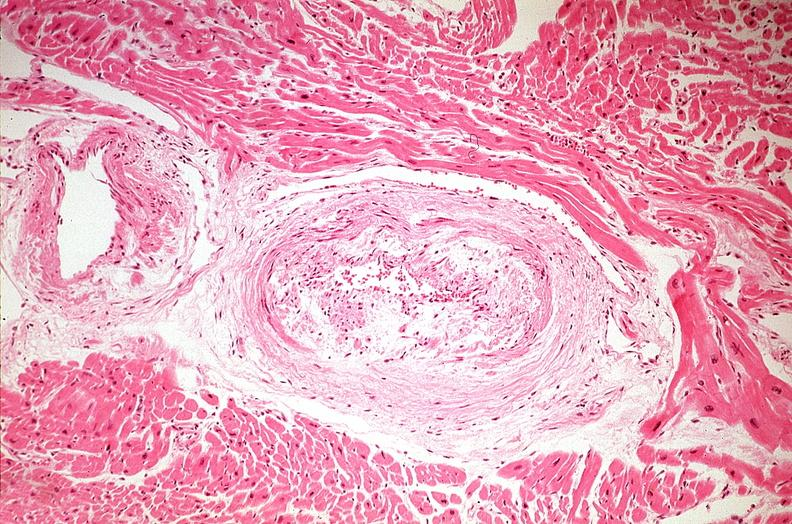what does this image show?
Answer the question using a single word or phrase. Heart 